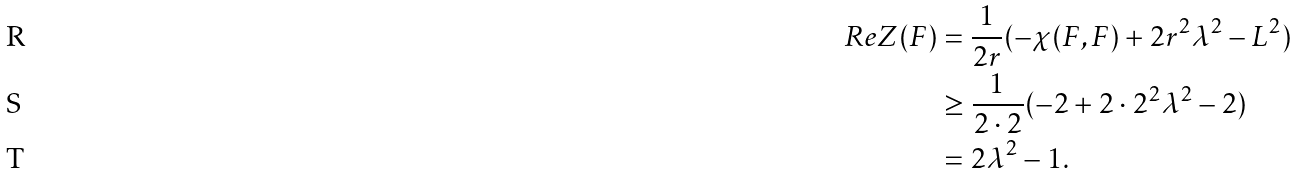<formula> <loc_0><loc_0><loc_500><loc_500>R e Z ( F ) & = \frac { 1 } { 2 r } ( - \chi ( F , F ) + 2 r ^ { 2 } \lambda ^ { 2 } - L ^ { 2 } ) \\ & \geq \frac { 1 } { 2 \cdot 2 } ( - 2 + 2 \cdot 2 ^ { 2 } \lambda ^ { 2 } - 2 ) \\ & = 2 \lambda ^ { 2 } - 1 .</formula> 